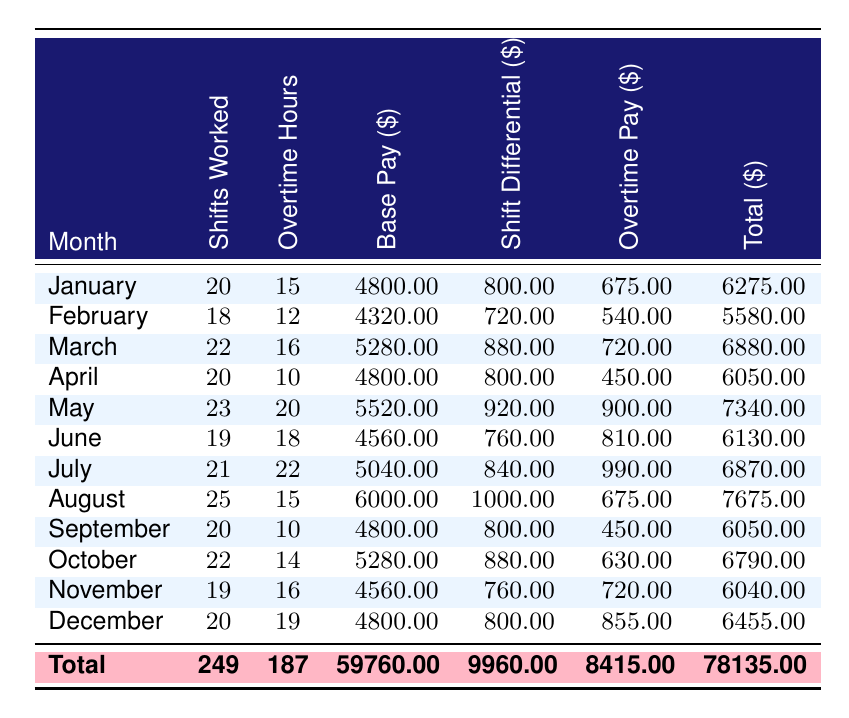What is the total number of shifts worked by Akira Tanaka in the year? To find the total number of shifts worked in the year, we sum the shifts worked for each month. The data shows 20 (January) + 18 (February) + 22 (March) + 20 (April) + 23 (May) + 19 (June) + 21 (July) + 25 (August) + 20 (September) + 22 (October) + 19 (November) + 20 (December) = 249.
Answer: 249 How much did Akira earn in shift differentials throughout the year? The total shift differentials for the year are stated in the amortization details. It indicates a cumulative total of $9960 for all the months.
Answer: 9960 Did Akira work overtime in every month of the year? To answer this, we check the overtime hours for each month listed. The overtime details show that there is at least one month (for example, February) where Akira worked overtime hours (12), hence confirming he did work overtime in every month. Therefore, the answer is true.
Answer: Yes What is the average overtime pay per month for Akira? The total overtime pay for the year is $8415. To find the average, we divide the total by the number of months: $8415 / 12 = $701.25.
Answer: 701.25 Which month had the highest total compensation? We determine the total compensation for each month from the data presented, looking for the maximum amount. Evaluating each month's total shows May has the highest total of $7340, making it the month with the highest compensation.
Answer: May What was Akira's base pay for the month of July? From the monthly data for July, we see that the base pay is noted specifically for the month as $5040.
Answer: 5040 Was the total compensation for the year more than $60000? The total compensation for the year is listed as $67650. Since $67650 is greater than $60000, the statement is true.
Answer: Yes How much more did Akira earn in overtime pay compared to the shift differential pay for the year? The total overtime pay is $8415 and the total shift differentials is $9960. To find the difference, we subtract the shift differential pay from the overtime pay: $8415 - $9960 = -$1545. In this case, Akira earned less from overtime pay than from shift differentials.
Answer: -1545 What was the total base pay earned in December? Looking at the December data from the table, the base pay specified for that month is $4800.
Answer: 4800 